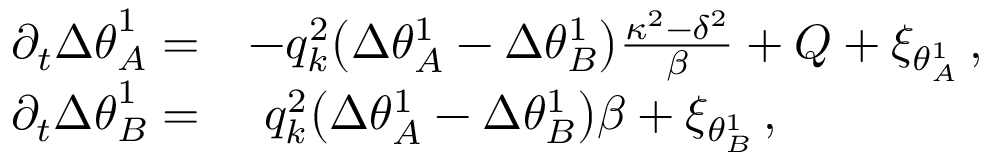<formula> <loc_0><loc_0><loc_500><loc_500>\begin{array} { r l } { \partial _ { t } { \Delta \theta } _ { A } ^ { 1 } = } & { - q _ { k } ^ { 2 } \left ( \Delta \theta _ { A } ^ { 1 } - \Delta \theta _ { B } ^ { 1 } \right ) \frac { \kappa ^ { 2 } - \delta ^ { 2 } } { \beta } + Q + \xi _ { \theta _ { A } ^ { 1 } } \, , } \\ { \partial _ { t } { \Delta \theta } _ { B } ^ { 1 } = } & { q _ { k } ^ { 2 } \left ( \Delta \theta _ { A } ^ { 1 } - \Delta \theta _ { B } ^ { 1 } \right ) \beta + \xi _ { \theta _ { B } ^ { 1 } } \, , } \end{array}</formula> 